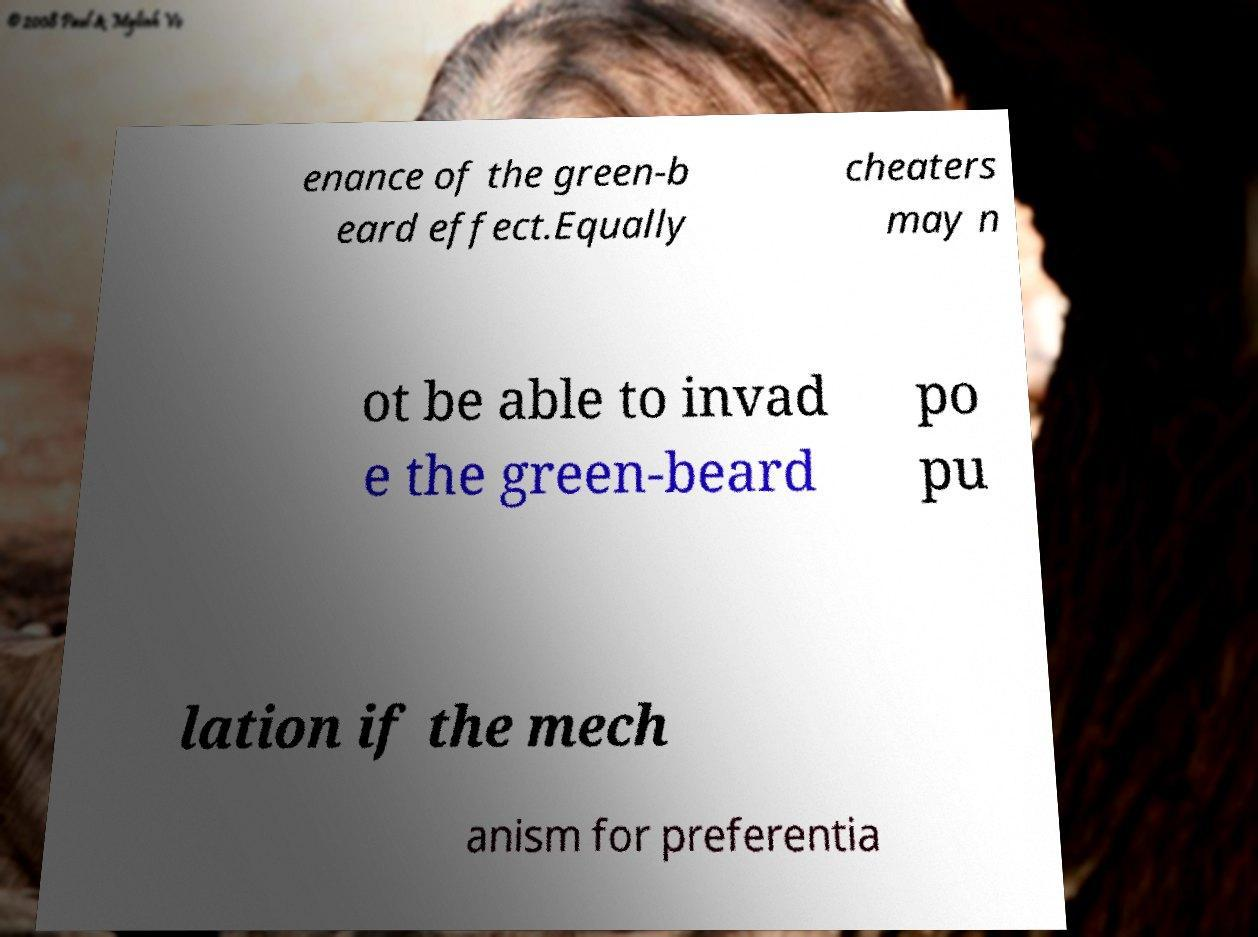Can you accurately transcribe the text from the provided image for me? enance of the green-b eard effect.Equally cheaters may n ot be able to invad e the green-beard po pu lation if the mech anism for preferentia 